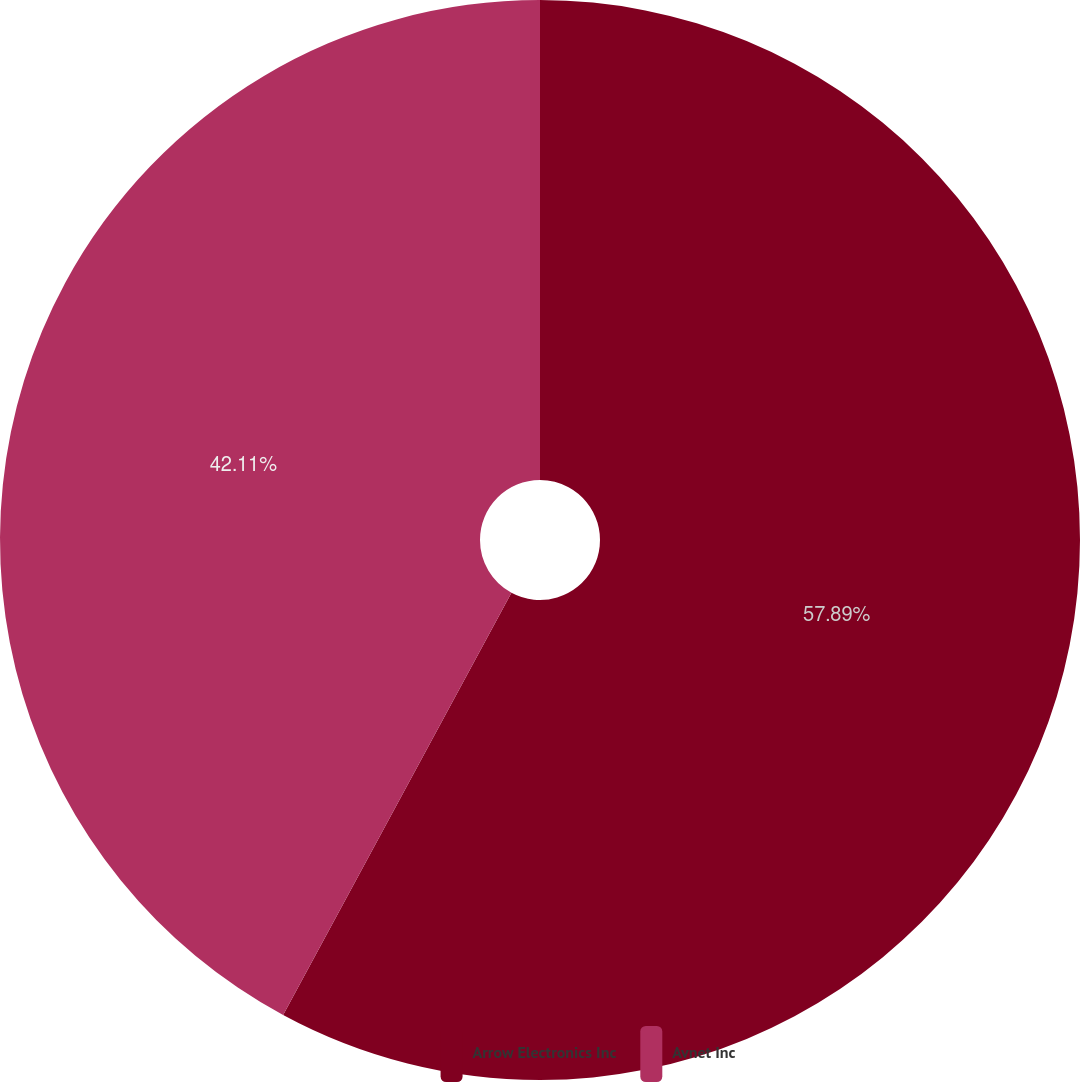Convert chart to OTSL. <chart><loc_0><loc_0><loc_500><loc_500><pie_chart><fcel>Arrow Electronics Inc<fcel>Avnet Inc<nl><fcel>57.89%<fcel>42.11%<nl></chart> 